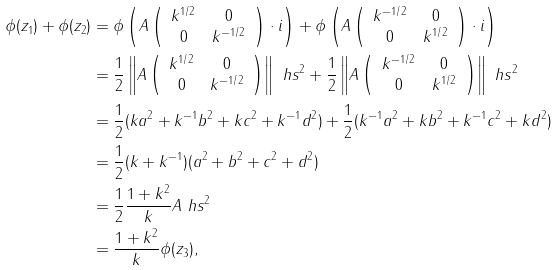Convert formula to latex. <formula><loc_0><loc_0><loc_500><loc_500>\phi ( z _ { 1 } ) + \phi ( z _ { 2 } ) & = \phi \left ( A \left ( \begin{array} { c c } k ^ { 1 / 2 } & 0 \\ 0 & k ^ { - 1 / 2 } \end{array} \right ) \cdot i \right ) + \phi \left ( A \left ( \begin{array} { c c } k ^ { - 1 / 2 } & 0 \\ 0 & k ^ { 1 / 2 } \end{array} \right ) \cdot i \right ) \\ & = \frac { 1 } { 2 } \left \| A \left ( \begin{array} { c c } k ^ { 1 / 2 } & 0 \\ 0 & k ^ { - 1 / 2 } \end{array} \right ) \right \| _ { \ } h s ^ { 2 } + \frac { 1 } { 2 } \left \| A \left ( \begin{array} { c c } k ^ { - 1 / 2 } & 0 \\ 0 & k ^ { 1 / 2 } \end{array} \right ) \right \| _ { \ } h s ^ { 2 } \\ & = \frac { 1 } { 2 } ( k a ^ { 2 } + k ^ { - 1 } b ^ { 2 } + k c ^ { 2 } + k ^ { - 1 } d ^ { 2 } ) + \frac { 1 } { 2 } ( k ^ { - 1 } a ^ { 2 } + k b ^ { 2 } + k ^ { - 1 } c ^ { 2 } + k d ^ { 2 } ) \\ & = \frac { 1 } { 2 } ( k + k ^ { - 1 } ) ( a ^ { 2 } + b ^ { 2 } + c ^ { 2 } + d ^ { 2 } ) \\ & = \frac { 1 } { 2 } \frac { 1 + k ^ { 2 } } { k } \| A \| _ { \ } h s ^ { 2 } \\ & = \frac { 1 + k ^ { 2 } } { k } \phi ( z _ { 3 } ) ,</formula> 